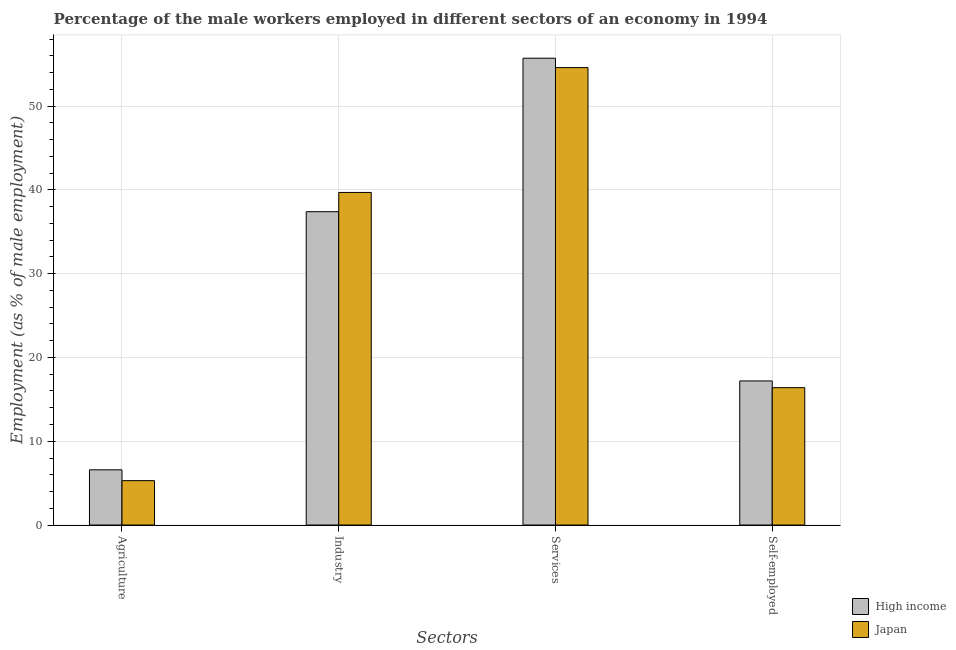How many groups of bars are there?
Keep it short and to the point. 4. How many bars are there on the 3rd tick from the left?
Make the answer very short. 2. What is the label of the 2nd group of bars from the left?
Offer a terse response. Industry. What is the percentage of male workers in industry in High income?
Provide a succinct answer. 37.4. Across all countries, what is the maximum percentage of male workers in industry?
Offer a very short reply. 39.7. Across all countries, what is the minimum percentage of male workers in industry?
Provide a short and direct response. 37.4. In which country was the percentage of male workers in industry maximum?
Your response must be concise. Japan. In which country was the percentage of self employed male workers minimum?
Your response must be concise. Japan. What is the total percentage of male workers in industry in the graph?
Offer a very short reply. 77.1. What is the difference between the percentage of male workers in agriculture in Japan and that in High income?
Ensure brevity in your answer.  -1.29. What is the difference between the percentage of male workers in industry in Japan and the percentage of male workers in agriculture in High income?
Keep it short and to the point. 33.11. What is the average percentage of male workers in agriculture per country?
Ensure brevity in your answer.  5.95. What is the difference between the percentage of male workers in services and percentage of male workers in industry in Japan?
Your answer should be very brief. 14.9. In how many countries, is the percentage of male workers in services greater than 38 %?
Provide a short and direct response. 2. What is the ratio of the percentage of male workers in industry in High income to that in Japan?
Keep it short and to the point. 0.94. Is the percentage of male workers in services in High income less than that in Japan?
Give a very brief answer. No. What is the difference between the highest and the second highest percentage of male workers in services?
Give a very brief answer. 1.12. What is the difference between the highest and the lowest percentage of male workers in agriculture?
Ensure brevity in your answer.  1.29. Is it the case that in every country, the sum of the percentage of male workers in agriculture and percentage of male workers in services is greater than the sum of percentage of male workers in industry and percentage of self employed male workers?
Your answer should be very brief. No. What does the 2nd bar from the left in Services represents?
Make the answer very short. Japan. What does the 1st bar from the right in Services represents?
Your answer should be very brief. Japan. Is it the case that in every country, the sum of the percentage of male workers in agriculture and percentage of male workers in industry is greater than the percentage of male workers in services?
Keep it short and to the point. No. What is the difference between two consecutive major ticks on the Y-axis?
Your answer should be compact. 10. Are the values on the major ticks of Y-axis written in scientific E-notation?
Your response must be concise. No. Does the graph contain grids?
Keep it short and to the point. Yes. How are the legend labels stacked?
Your response must be concise. Vertical. What is the title of the graph?
Provide a succinct answer. Percentage of the male workers employed in different sectors of an economy in 1994. What is the label or title of the X-axis?
Offer a terse response. Sectors. What is the label or title of the Y-axis?
Provide a succinct answer. Employment (as % of male employment). What is the Employment (as % of male employment) of High income in Agriculture?
Ensure brevity in your answer.  6.59. What is the Employment (as % of male employment) of Japan in Agriculture?
Provide a short and direct response. 5.3. What is the Employment (as % of male employment) in High income in Industry?
Ensure brevity in your answer.  37.4. What is the Employment (as % of male employment) in Japan in Industry?
Provide a short and direct response. 39.7. What is the Employment (as % of male employment) in High income in Services?
Offer a terse response. 55.72. What is the Employment (as % of male employment) in Japan in Services?
Ensure brevity in your answer.  54.6. What is the Employment (as % of male employment) of High income in Self-employed?
Provide a short and direct response. 17.2. What is the Employment (as % of male employment) of Japan in Self-employed?
Your response must be concise. 16.4. Across all Sectors, what is the maximum Employment (as % of male employment) in High income?
Offer a terse response. 55.72. Across all Sectors, what is the maximum Employment (as % of male employment) of Japan?
Provide a short and direct response. 54.6. Across all Sectors, what is the minimum Employment (as % of male employment) in High income?
Give a very brief answer. 6.59. Across all Sectors, what is the minimum Employment (as % of male employment) of Japan?
Give a very brief answer. 5.3. What is the total Employment (as % of male employment) of High income in the graph?
Give a very brief answer. 116.92. What is the total Employment (as % of male employment) of Japan in the graph?
Offer a terse response. 116. What is the difference between the Employment (as % of male employment) of High income in Agriculture and that in Industry?
Provide a short and direct response. -30.81. What is the difference between the Employment (as % of male employment) in Japan in Agriculture and that in Industry?
Offer a very short reply. -34.4. What is the difference between the Employment (as % of male employment) in High income in Agriculture and that in Services?
Give a very brief answer. -49.13. What is the difference between the Employment (as % of male employment) in Japan in Agriculture and that in Services?
Keep it short and to the point. -49.3. What is the difference between the Employment (as % of male employment) in High income in Agriculture and that in Self-employed?
Your response must be concise. -10.61. What is the difference between the Employment (as % of male employment) of High income in Industry and that in Services?
Make the answer very short. -18.32. What is the difference between the Employment (as % of male employment) in Japan in Industry and that in Services?
Keep it short and to the point. -14.9. What is the difference between the Employment (as % of male employment) in High income in Industry and that in Self-employed?
Offer a very short reply. 20.2. What is the difference between the Employment (as % of male employment) in Japan in Industry and that in Self-employed?
Ensure brevity in your answer.  23.3. What is the difference between the Employment (as % of male employment) of High income in Services and that in Self-employed?
Your answer should be very brief. 38.52. What is the difference between the Employment (as % of male employment) of Japan in Services and that in Self-employed?
Give a very brief answer. 38.2. What is the difference between the Employment (as % of male employment) of High income in Agriculture and the Employment (as % of male employment) of Japan in Industry?
Your answer should be compact. -33.11. What is the difference between the Employment (as % of male employment) of High income in Agriculture and the Employment (as % of male employment) of Japan in Services?
Your answer should be compact. -48.01. What is the difference between the Employment (as % of male employment) in High income in Agriculture and the Employment (as % of male employment) in Japan in Self-employed?
Make the answer very short. -9.81. What is the difference between the Employment (as % of male employment) of High income in Industry and the Employment (as % of male employment) of Japan in Services?
Make the answer very short. -17.2. What is the difference between the Employment (as % of male employment) of High income in Industry and the Employment (as % of male employment) of Japan in Self-employed?
Make the answer very short. 21. What is the difference between the Employment (as % of male employment) of High income in Services and the Employment (as % of male employment) of Japan in Self-employed?
Your answer should be very brief. 39.32. What is the average Employment (as % of male employment) of High income per Sectors?
Keep it short and to the point. 29.23. What is the average Employment (as % of male employment) of Japan per Sectors?
Give a very brief answer. 29. What is the difference between the Employment (as % of male employment) in High income and Employment (as % of male employment) in Japan in Agriculture?
Keep it short and to the point. 1.29. What is the difference between the Employment (as % of male employment) in High income and Employment (as % of male employment) in Japan in Industry?
Your answer should be compact. -2.3. What is the difference between the Employment (as % of male employment) of High income and Employment (as % of male employment) of Japan in Services?
Your response must be concise. 1.12. What is the difference between the Employment (as % of male employment) in High income and Employment (as % of male employment) in Japan in Self-employed?
Your response must be concise. 0.8. What is the ratio of the Employment (as % of male employment) in High income in Agriculture to that in Industry?
Offer a very short reply. 0.18. What is the ratio of the Employment (as % of male employment) of Japan in Agriculture to that in Industry?
Provide a succinct answer. 0.13. What is the ratio of the Employment (as % of male employment) in High income in Agriculture to that in Services?
Your answer should be compact. 0.12. What is the ratio of the Employment (as % of male employment) of Japan in Agriculture to that in Services?
Ensure brevity in your answer.  0.1. What is the ratio of the Employment (as % of male employment) of High income in Agriculture to that in Self-employed?
Provide a short and direct response. 0.38. What is the ratio of the Employment (as % of male employment) in Japan in Agriculture to that in Self-employed?
Ensure brevity in your answer.  0.32. What is the ratio of the Employment (as % of male employment) of High income in Industry to that in Services?
Ensure brevity in your answer.  0.67. What is the ratio of the Employment (as % of male employment) in Japan in Industry to that in Services?
Make the answer very short. 0.73. What is the ratio of the Employment (as % of male employment) of High income in Industry to that in Self-employed?
Your answer should be very brief. 2.17. What is the ratio of the Employment (as % of male employment) of Japan in Industry to that in Self-employed?
Offer a terse response. 2.42. What is the ratio of the Employment (as % of male employment) of High income in Services to that in Self-employed?
Give a very brief answer. 3.24. What is the ratio of the Employment (as % of male employment) in Japan in Services to that in Self-employed?
Your response must be concise. 3.33. What is the difference between the highest and the second highest Employment (as % of male employment) of High income?
Your answer should be very brief. 18.32. What is the difference between the highest and the second highest Employment (as % of male employment) of Japan?
Keep it short and to the point. 14.9. What is the difference between the highest and the lowest Employment (as % of male employment) of High income?
Your response must be concise. 49.13. What is the difference between the highest and the lowest Employment (as % of male employment) of Japan?
Offer a very short reply. 49.3. 